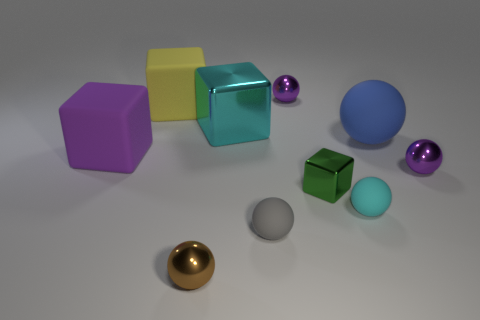The large cube that is on the right side of the small object that is to the left of the gray rubber ball is what color?
Keep it short and to the point. Cyan. Do the brown metal object and the yellow object have the same size?
Keep it short and to the point. No. Is the sphere that is right of the big blue rubber thing made of the same material as the purple thing that is behind the blue rubber object?
Keep it short and to the point. Yes. What is the shape of the purple object left of the small rubber thing that is left of the purple sphere that is behind the purple block?
Keep it short and to the point. Cube. Are there more blue spheres than large red rubber cubes?
Provide a succinct answer. Yes. Are there any tiny green metal objects?
Ensure brevity in your answer.  Yes. How many objects are either tiny metallic objects on the right side of the brown shiny object or large spheres on the right side of the purple rubber block?
Your answer should be very brief. 4. Is the tiny metal block the same color as the big ball?
Make the answer very short. No. Is the number of cyan rubber things less than the number of tiny red shiny cylinders?
Provide a short and direct response. No. There is a yellow thing; are there any small purple shiny things behind it?
Offer a very short reply. Yes. 